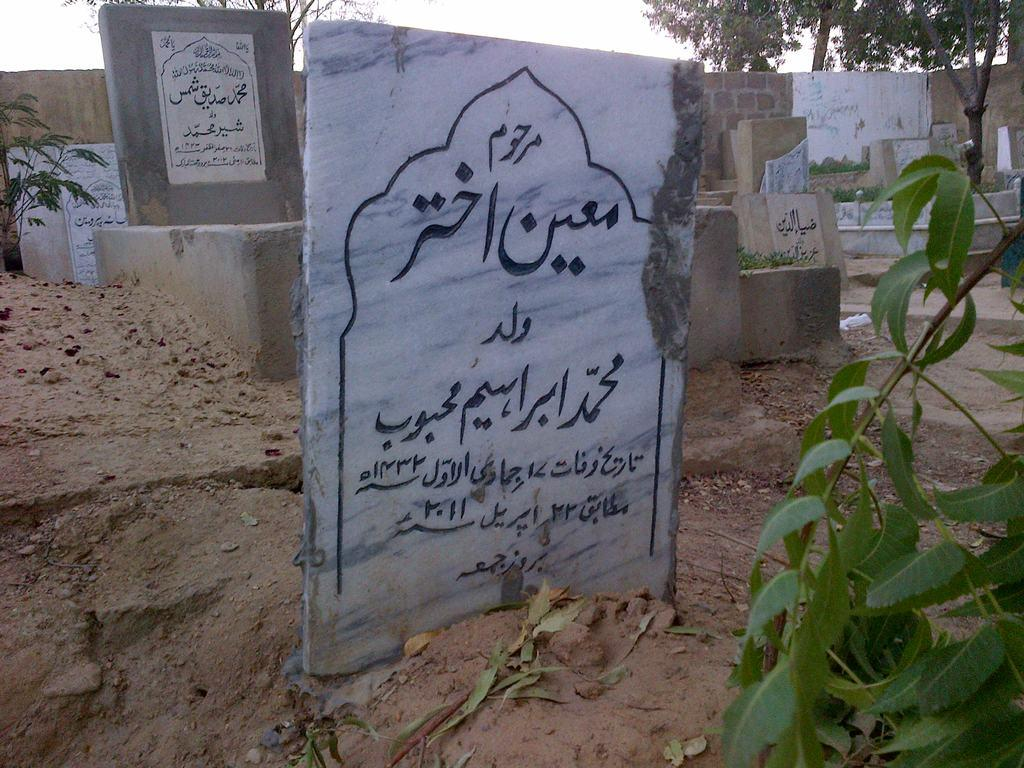What type of material is used for the boards in the image? The boards in the image are made of stone. What other elements can be seen in the image besides the stone boards? There are plants and a wall visible in the image. What can be seen in the background of the image? There are trees and the sky visible in the background of the image. What type of rhythm can be heard from the quilt in the image? There is no quilt present in the image, and therefore no rhythm can be heard from it. 